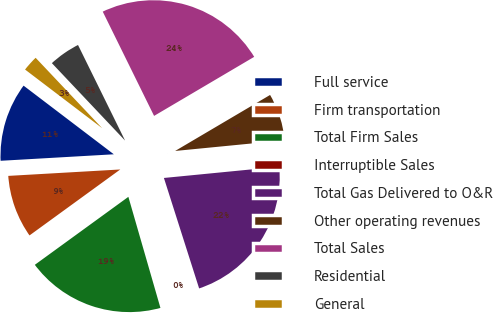<chart> <loc_0><loc_0><loc_500><loc_500><pie_chart><fcel>Full service<fcel>Firm transportation<fcel>Total Firm Sales<fcel>Interruptible Sales<fcel>Total Gas Delivered to O&R<fcel>Other operating revenues<fcel>Total Sales<fcel>Residential<fcel>General<nl><fcel>11.26%<fcel>9.09%<fcel>19.47%<fcel>0.44%<fcel>21.64%<fcel>6.93%<fcel>23.8%<fcel>4.77%<fcel>2.6%<nl></chart> 